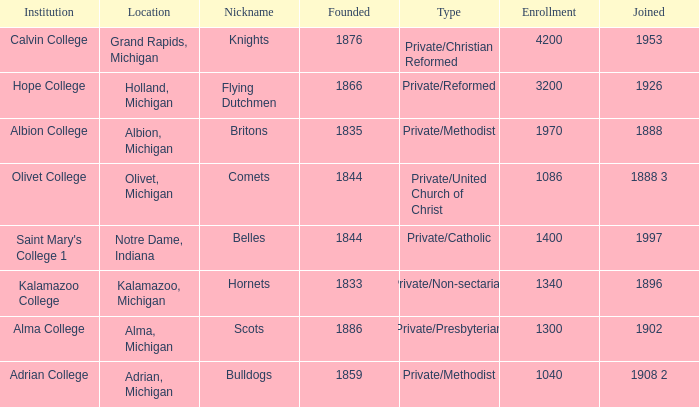In 1953, which of the institutions joined? Calvin College. 